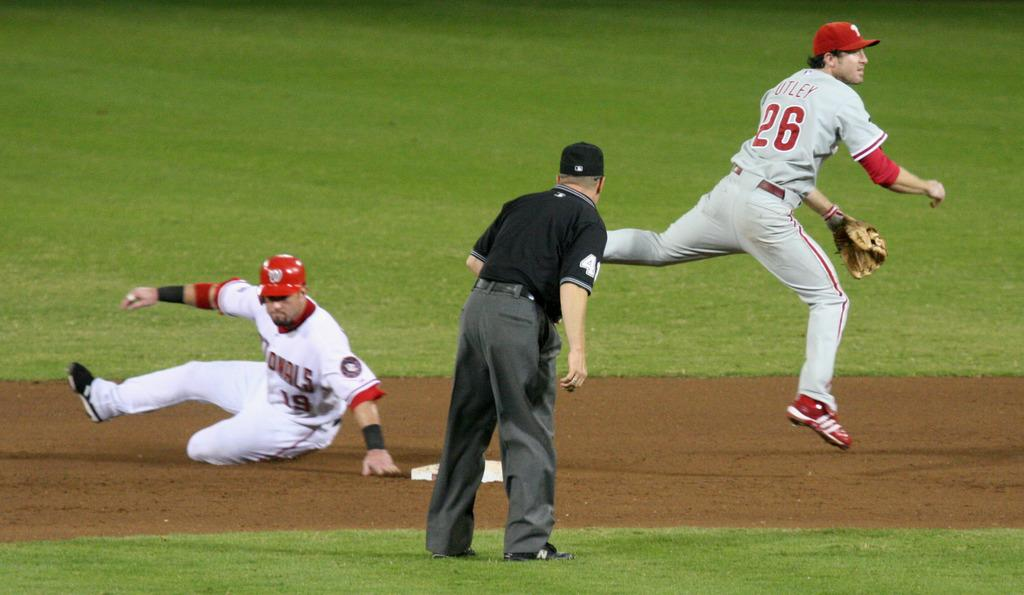Provide a one-sentence caption for the provided image. A runner slides to the second base as the second baseman leaps over and throws to the first base. 